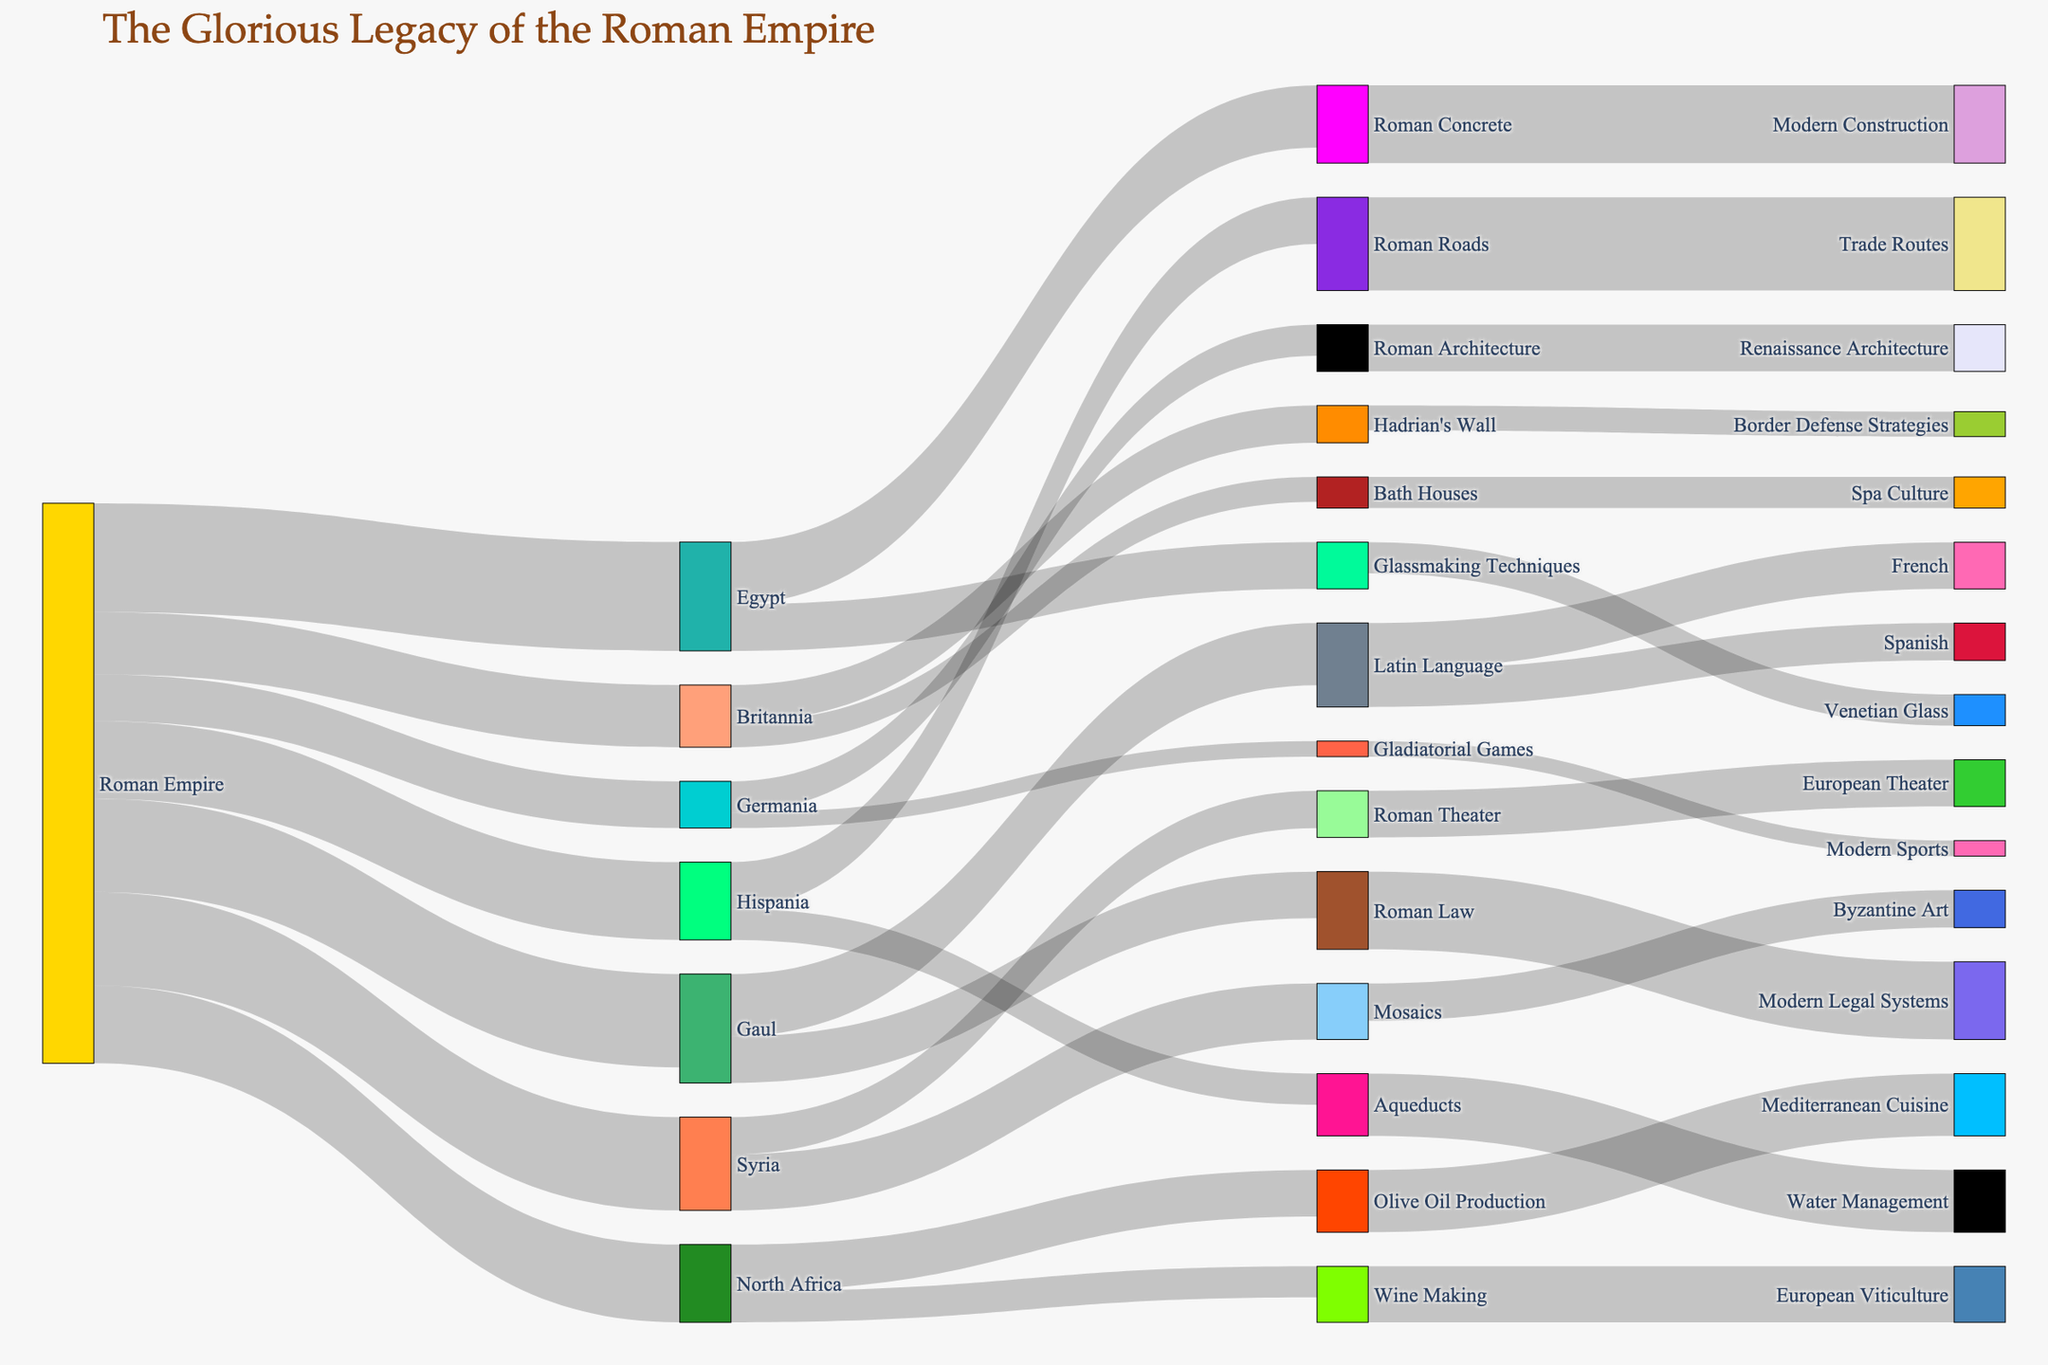Which region received the most technological transfer from the Roman Empire? By examining the values associated with each region, Egypt received 35 units, the highest amount.
Answer: Egypt What cultural transfer from the Roman Empire influenced the most different aspects in the target regions? Latin Language influenced both French and Spanish with values of 15 and 12 respectively, totaling 27, making it a significant cultural transfer.
Answer: Latin Language How many regions were influenced by the Roman Empire according to the chart? By counting the unique target regions listed: Gaul, Hispania, Britannia, Germania, Egypt, Syria, and North Africa—there are 7 regions.
Answer: 7 Which cultural aspect influenced modern legal systems, and how many units of influence does it hold? Roman Law is the source influencing modern legal systems with a value of 25 units.
Answer: Roman Law, 25 units Compare the technological transfers between Egypt and Hispania. Which region received more, and by how much? Egypt received 35 units, while Hispania received 25 combined from aqueducts (10) and Roman Roads (15). The difference is 35 - 25 = 10 units.
Answer: Egypt, 10 units What is the combined value of the influence of Roman architecture and Roman concrete on their respective target aspects? Roman Architecture influences Renaissance Architecture with a value of 15, and Roman Concrete influences Modern Construction with a value of 25; combined, this totals 15 + 25 = 40 units.
Answer: 40 units Which legacy of Roman influence contributes to Mediterranean cuisine, and how many units does it hold? Olive oil production from North Africa contributes to Mediterranean cuisine with a value of 20 units.
Answer: Olive oil production, 20 units What is the total influence value of Roman roads and bath houses combined? Roman Roads influence trade routes with 30 units, and Bath Houses influence spa culture with 10 units; combined, the total is 30 + 10 = 40 units.
Answer: 40 units Which influence transferred by the Roman Empire is reflected in European viticulture, and what is its value? Wine Making in North Africa influences European Viticulture with a value of 18 units.
Answer: Wine Making, 18 units 